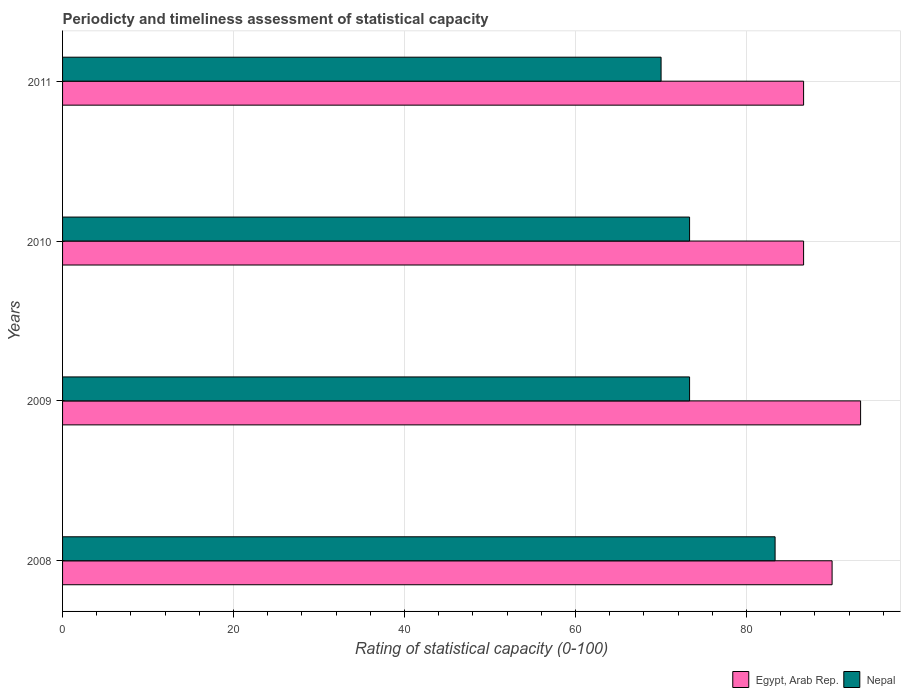How many groups of bars are there?
Offer a terse response. 4. Are the number of bars per tick equal to the number of legend labels?
Offer a very short reply. Yes. What is the rating of statistical capacity in Nepal in 2009?
Your response must be concise. 73.33. Across all years, what is the maximum rating of statistical capacity in Egypt, Arab Rep.?
Ensure brevity in your answer.  93.33. Across all years, what is the minimum rating of statistical capacity in Nepal?
Make the answer very short. 70. In which year was the rating of statistical capacity in Egypt, Arab Rep. minimum?
Provide a succinct answer. 2010. What is the total rating of statistical capacity in Egypt, Arab Rep. in the graph?
Keep it short and to the point. 356.67. What is the difference between the rating of statistical capacity in Egypt, Arab Rep. in 2009 and that in 2010?
Keep it short and to the point. 6.67. What is the difference between the rating of statistical capacity in Nepal in 2010 and the rating of statistical capacity in Egypt, Arab Rep. in 2008?
Offer a very short reply. -16.67. What is the average rating of statistical capacity in Egypt, Arab Rep. per year?
Ensure brevity in your answer.  89.17. What is the ratio of the rating of statistical capacity in Egypt, Arab Rep. in 2008 to that in 2011?
Provide a short and direct response. 1.04. Is the difference between the rating of statistical capacity in Nepal in 2008 and 2010 greater than the difference between the rating of statistical capacity in Egypt, Arab Rep. in 2008 and 2010?
Your response must be concise. Yes. What is the difference between the highest and the second highest rating of statistical capacity in Egypt, Arab Rep.?
Your answer should be compact. 3.33. What is the difference between the highest and the lowest rating of statistical capacity in Egypt, Arab Rep.?
Keep it short and to the point. 6.67. In how many years, is the rating of statistical capacity in Nepal greater than the average rating of statistical capacity in Nepal taken over all years?
Provide a short and direct response. 1. What does the 1st bar from the top in 2010 represents?
Ensure brevity in your answer.  Nepal. What does the 1st bar from the bottom in 2008 represents?
Ensure brevity in your answer.  Egypt, Arab Rep. How many bars are there?
Keep it short and to the point. 8. Are all the bars in the graph horizontal?
Offer a very short reply. Yes. How are the legend labels stacked?
Provide a short and direct response. Horizontal. What is the title of the graph?
Provide a succinct answer. Periodicty and timeliness assessment of statistical capacity. Does "Belize" appear as one of the legend labels in the graph?
Make the answer very short. No. What is the label or title of the X-axis?
Your answer should be compact. Rating of statistical capacity (0-100). What is the label or title of the Y-axis?
Your response must be concise. Years. What is the Rating of statistical capacity (0-100) of Nepal in 2008?
Your answer should be very brief. 83.33. What is the Rating of statistical capacity (0-100) in Egypt, Arab Rep. in 2009?
Offer a terse response. 93.33. What is the Rating of statistical capacity (0-100) in Nepal in 2009?
Provide a short and direct response. 73.33. What is the Rating of statistical capacity (0-100) of Egypt, Arab Rep. in 2010?
Offer a very short reply. 86.67. What is the Rating of statistical capacity (0-100) of Nepal in 2010?
Your answer should be very brief. 73.33. What is the Rating of statistical capacity (0-100) of Egypt, Arab Rep. in 2011?
Provide a succinct answer. 86.67. Across all years, what is the maximum Rating of statistical capacity (0-100) of Egypt, Arab Rep.?
Your answer should be very brief. 93.33. Across all years, what is the maximum Rating of statistical capacity (0-100) in Nepal?
Keep it short and to the point. 83.33. Across all years, what is the minimum Rating of statistical capacity (0-100) of Egypt, Arab Rep.?
Your answer should be compact. 86.67. What is the total Rating of statistical capacity (0-100) in Egypt, Arab Rep. in the graph?
Your answer should be very brief. 356.67. What is the total Rating of statistical capacity (0-100) in Nepal in the graph?
Ensure brevity in your answer.  300. What is the difference between the Rating of statistical capacity (0-100) of Egypt, Arab Rep. in 2008 and that in 2009?
Provide a short and direct response. -3.33. What is the difference between the Rating of statistical capacity (0-100) in Egypt, Arab Rep. in 2008 and that in 2010?
Make the answer very short. 3.33. What is the difference between the Rating of statistical capacity (0-100) in Egypt, Arab Rep. in 2008 and that in 2011?
Make the answer very short. 3.33. What is the difference between the Rating of statistical capacity (0-100) of Nepal in 2008 and that in 2011?
Make the answer very short. 13.33. What is the difference between the Rating of statistical capacity (0-100) of Egypt, Arab Rep. in 2009 and that in 2010?
Your answer should be compact. 6.67. What is the difference between the Rating of statistical capacity (0-100) of Nepal in 2009 and that in 2010?
Provide a succinct answer. 0. What is the difference between the Rating of statistical capacity (0-100) in Nepal in 2009 and that in 2011?
Give a very brief answer. 3.33. What is the difference between the Rating of statistical capacity (0-100) of Egypt, Arab Rep. in 2008 and the Rating of statistical capacity (0-100) of Nepal in 2009?
Your response must be concise. 16.67. What is the difference between the Rating of statistical capacity (0-100) in Egypt, Arab Rep. in 2008 and the Rating of statistical capacity (0-100) in Nepal in 2010?
Your answer should be very brief. 16.67. What is the difference between the Rating of statistical capacity (0-100) of Egypt, Arab Rep. in 2009 and the Rating of statistical capacity (0-100) of Nepal in 2010?
Keep it short and to the point. 20. What is the difference between the Rating of statistical capacity (0-100) in Egypt, Arab Rep. in 2009 and the Rating of statistical capacity (0-100) in Nepal in 2011?
Keep it short and to the point. 23.33. What is the difference between the Rating of statistical capacity (0-100) of Egypt, Arab Rep. in 2010 and the Rating of statistical capacity (0-100) of Nepal in 2011?
Keep it short and to the point. 16.67. What is the average Rating of statistical capacity (0-100) in Egypt, Arab Rep. per year?
Give a very brief answer. 89.17. What is the average Rating of statistical capacity (0-100) of Nepal per year?
Offer a very short reply. 75. In the year 2010, what is the difference between the Rating of statistical capacity (0-100) of Egypt, Arab Rep. and Rating of statistical capacity (0-100) of Nepal?
Provide a short and direct response. 13.33. In the year 2011, what is the difference between the Rating of statistical capacity (0-100) of Egypt, Arab Rep. and Rating of statistical capacity (0-100) of Nepal?
Keep it short and to the point. 16.67. What is the ratio of the Rating of statistical capacity (0-100) of Nepal in 2008 to that in 2009?
Offer a terse response. 1.14. What is the ratio of the Rating of statistical capacity (0-100) in Nepal in 2008 to that in 2010?
Make the answer very short. 1.14. What is the ratio of the Rating of statistical capacity (0-100) of Egypt, Arab Rep. in 2008 to that in 2011?
Keep it short and to the point. 1.04. What is the ratio of the Rating of statistical capacity (0-100) in Nepal in 2008 to that in 2011?
Your response must be concise. 1.19. What is the ratio of the Rating of statistical capacity (0-100) of Egypt, Arab Rep. in 2009 to that in 2010?
Provide a succinct answer. 1.08. What is the ratio of the Rating of statistical capacity (0-100) in Nepal in 2009 to that in 2010?
Provide a succinct answer. 1. What is the ratio of the Rating of statistical capacity (0-100) in Nepal in 2009 to that in 2011?
Offer a terse response. 1.05. What is the ratio of the Rating of statistical capacity (0-100) in Nepal in 2010 to that in 2011?
Give a very brief answer. 1.05. What is the difference between the highest and the second highest Rating of statistical capacity (0-100) in Egypt, Arab Rep.?
Give a very brief answer. 3.33. What is the difference between the highest and the second highest Rating of statistical capacity (0-100) of Nepal?
Give a very brief answer. 10. What is the difference between the highest and the lowest Rating of statistical capacity (0-100) in Nepal?
Provide a succinct answer. 13.33. 